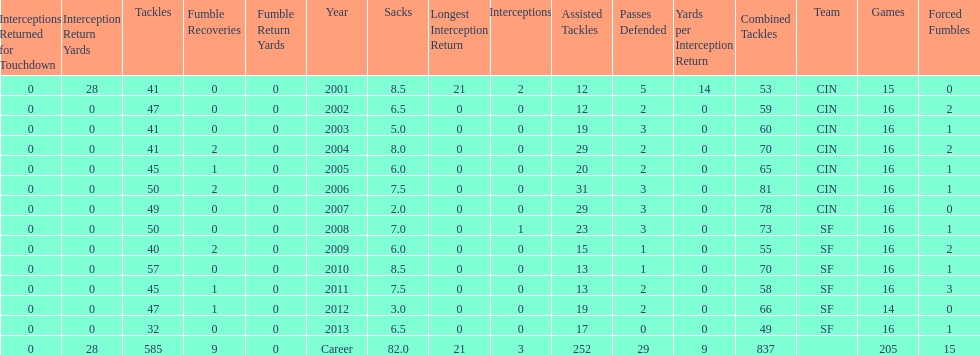Help me parse the entirety of this table. {'header': ['Interceptions Returned for Touchdown', 'Interception Return Yards', 'Tackles', 'Fumble Recoveries', 'Fumble Return Yards', 'Year', 'Sacks', 'Longest Interception Return', 'Interceptions', 'Assisted Tackles', 'Passes Defended', 'Yards per Interception Return', 'Combined Tackles', 'Team', 'Games', 'Forced Fumbles'], 'rows': [['0', '28', '41', '0', '0', '2001', '8.5', '21', '2', '12', '5', '14', '53', 'CIN', '15', '0'], ['0', '0', '47', '0', '0', '2002', '6.5', '0', '0', '12', '2', '0', '59', 'CIN', '16', '2'], ['0', '0', '41', '0', '0', '2003', '5.0', '0', '0', '19', '3', '0', '60', 'CIN', '16', '1'], ['0', '0', '41', '2', '0', '2004', '8.0', '0', '0', '29', '2', '0', '70', 'CIN', '16', '2'], ['0', '0', '45', '1', '0', '2005', '6.0', '0', '0', '20', '2', '0', '65', 'CIN', '16', '1'], ['0', '0', '50', '2', '0', '2006', '7.5', '0', '0', '31', '3', '0', '81', 'CIN', '16', '1'], ['0', '0', '49', '0', '0', '2007', '2.0', '0', '0', '29', '3', '0', '78', 'CIN', '16', '0'], ['0', '0', '50', '0', '0', '2008', '7.0', '0', '1', '23', '3', '0', '73', 'SF', '16', '1'], ['0', '0', '40', '2', '0', '2009', '6.0', '0', '0', '15', '1', '0', '55', 'SF', '16', '2'], ['0', '0', '57', '0', '0', '2010', '8.5', '0', '0', '13', '1', '0', '70', 'SF', '16', '1'], ['0', '0', '45', '1', '0', '2011', '7.5', '0', '0', '13', '2', '0', '58', 'SF', '16', '3'], ['0', '0', '47', '1', '0', '2012', '3.0', '0', '0', '19', '2', '0', '66', 'SF', '14', '0'], ['0', '0', '32', '0', '0', '2013', '6.5', '0', '0', '17', '0', '0', '49', 'SF', '16', '1'], ['0', '28', '585', '9', '0', 'Career', '82.0', '21', '3', '252', '29', '9', '837', '', '205', '15']]} How many fumble recoveries did this player have in 2004? 2. 